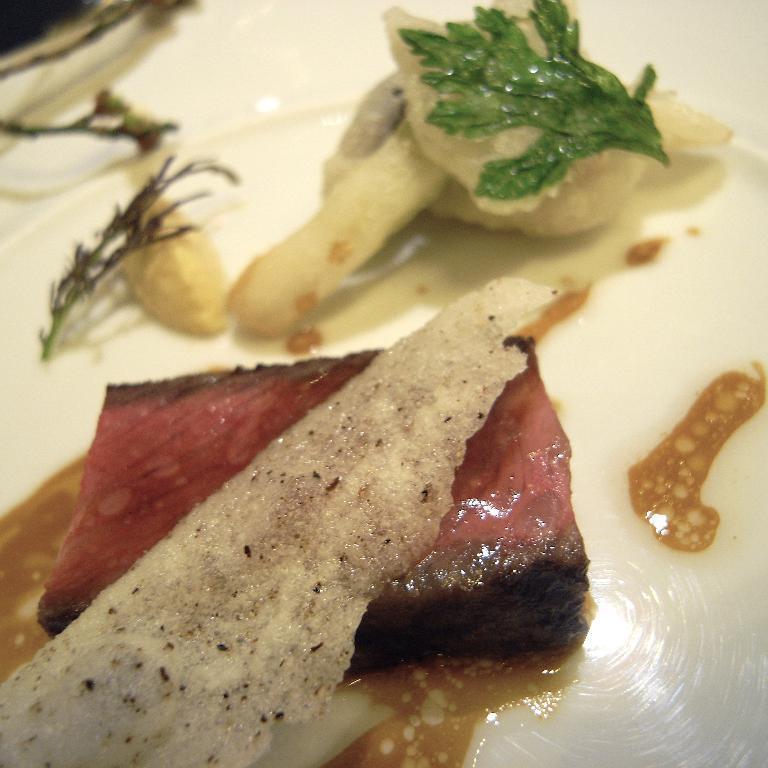Describe this image in one or two sentences. In this picture we can see a plate at the bottom, there is some food present in the plate. 